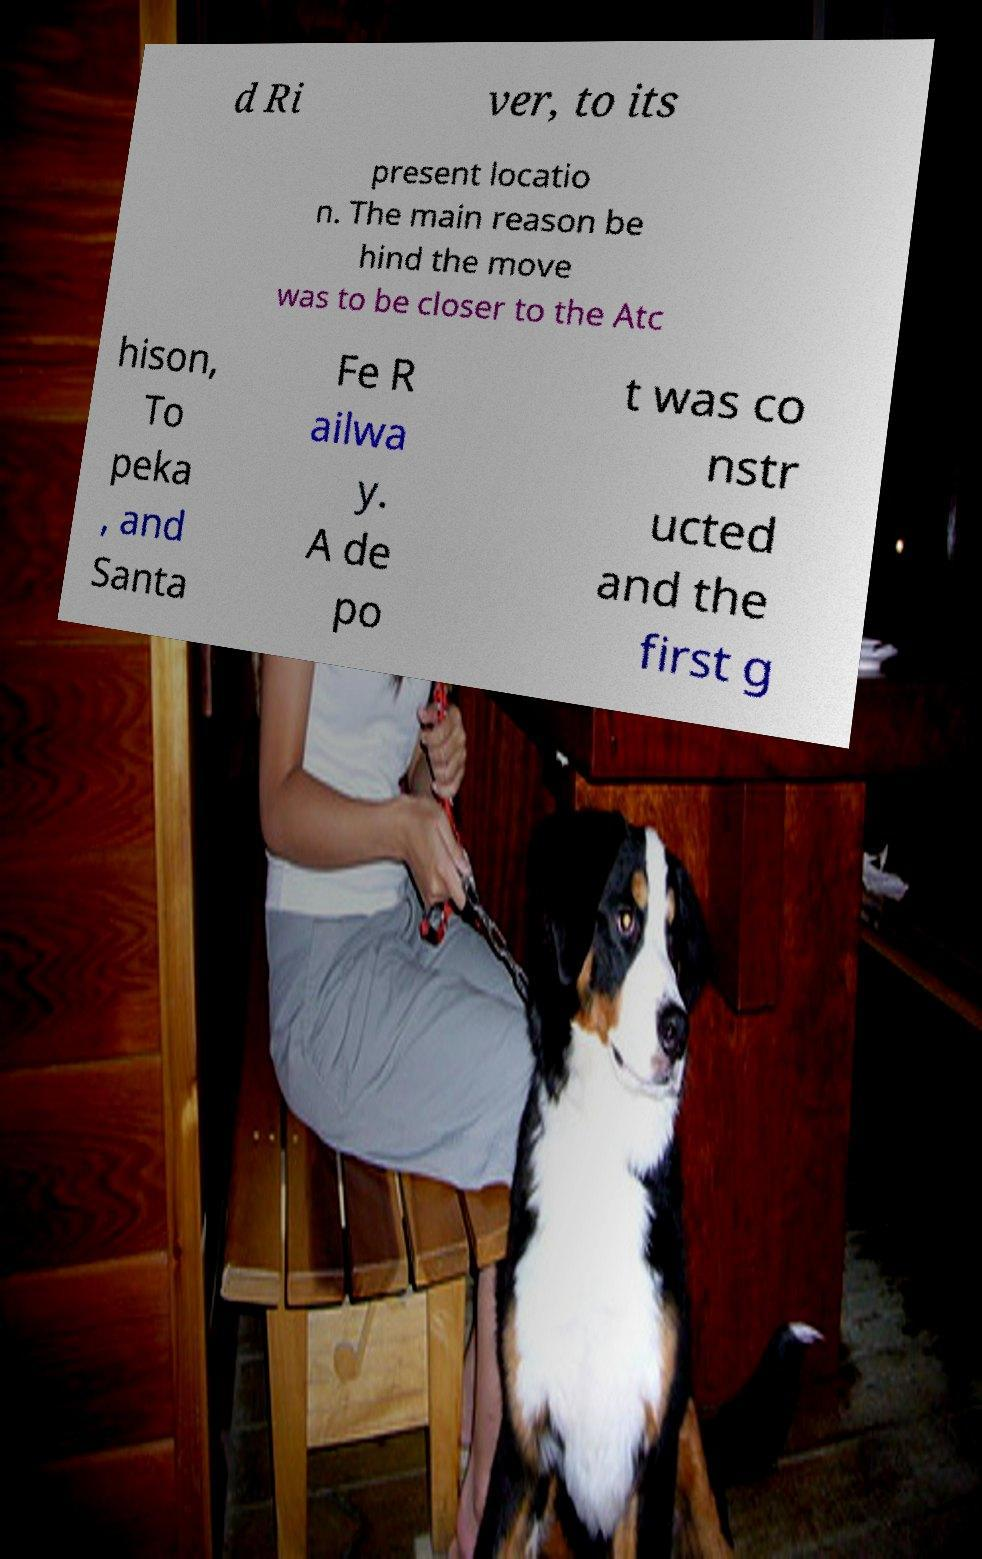Can you accurately transcribe the text from the provided image for me? d Ri ver, to its present locatio n. The main reason be hind the move was to be closer to the Atc hison, To peka , and Santa Fe R ailwa y. A de po t was co nstr ucted and the first g 